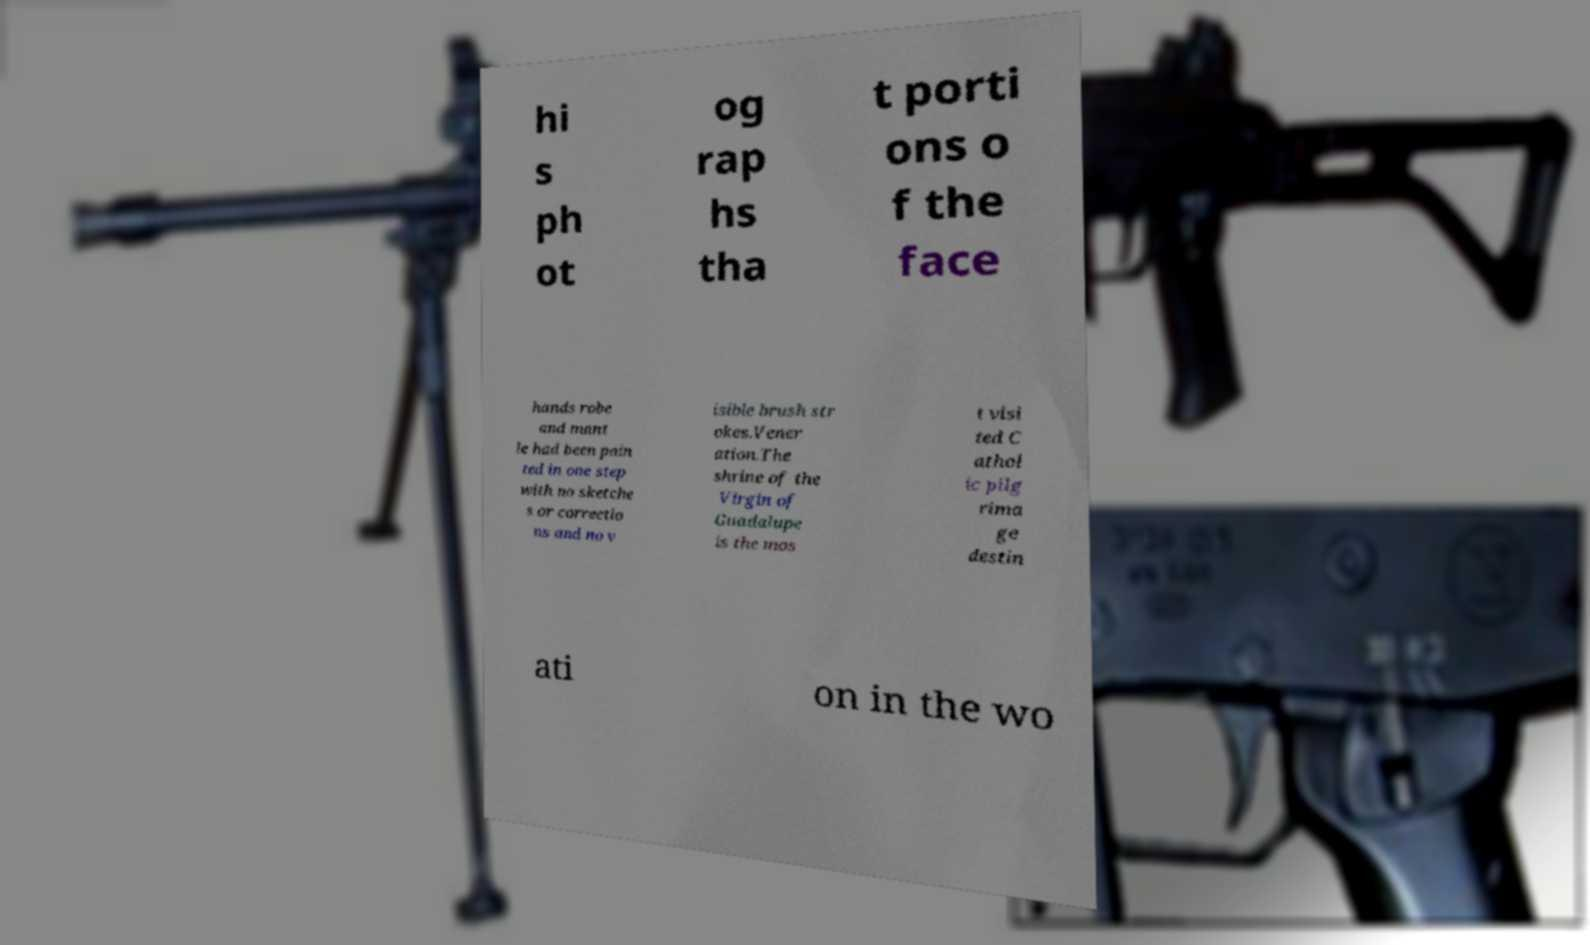Can you accurately transcribe the text from the provided image for me? hi s ph ot og rap hs tha t porti ons o f the face hands robe and mant le had been pain ted in one step with no sketche s or correctio ns and no v isible brush str okes.Vener ation.The shrine of the Virgin of Guadalupe is the mos t visi ted C athol ic pilg rima ge destin ati on in the wo 